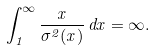Convert formula to latex. <formula><loc_0><loc_0><loc_500><loc_500>\int _ { 1 } ^ { \infty } \frac { x } { \sigma ^ { 2 } ( x ) } \, d x = \infty .</formula> 